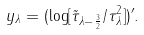<formula> <loc_0><loc_0><loc_500><loc_500>y _ { \lambda } = ( \log [ \tilde { \tau } _ { \lambda - \frac { 3 } { 2 } } / \tau _ { \lambda } ^ { 2 } ] ) ^ { \prime } .</formula> 